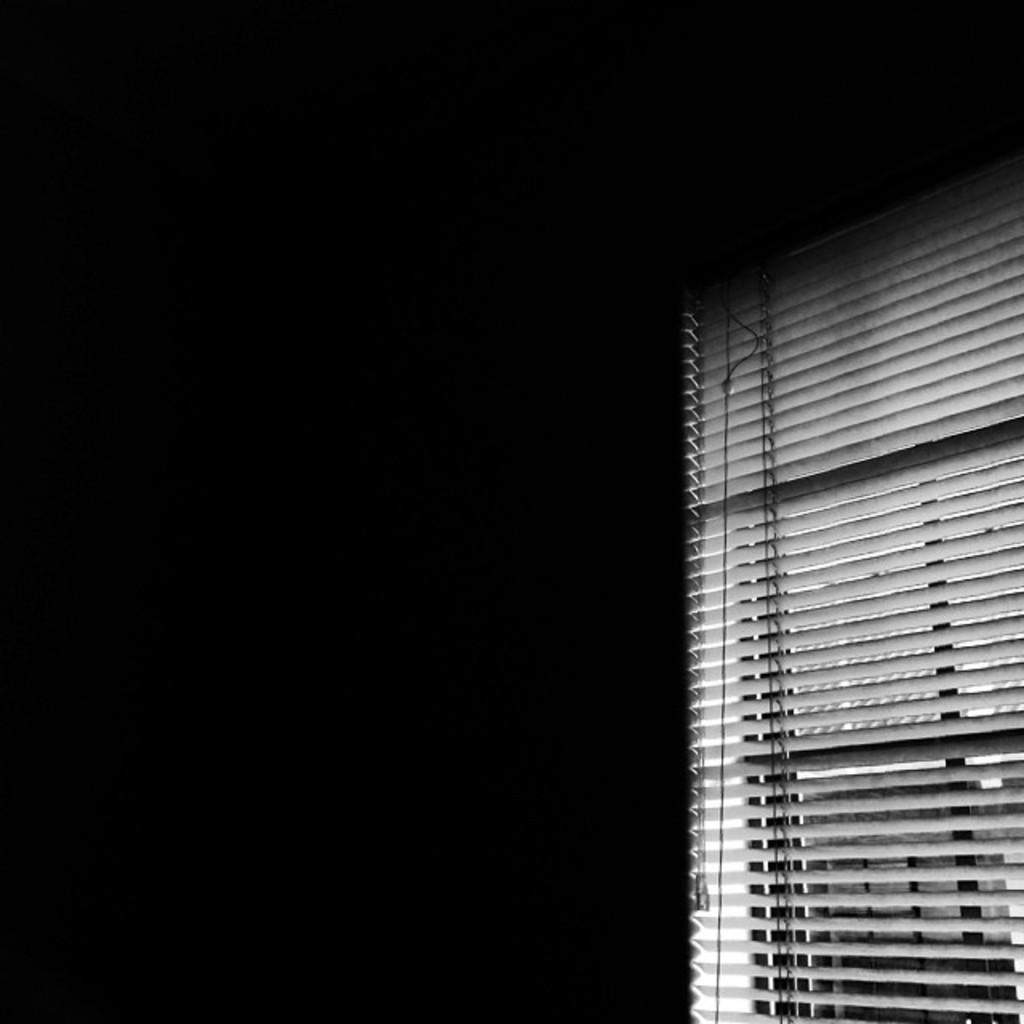What is located on the right side of the image? There is a window on the right side of the image. How would you describe the overall lighting in the image? The background of the image appears to be dark. What type of punishment is being administered in the image? There is no indication of punishment in the image; it only features a window and a dark background. 